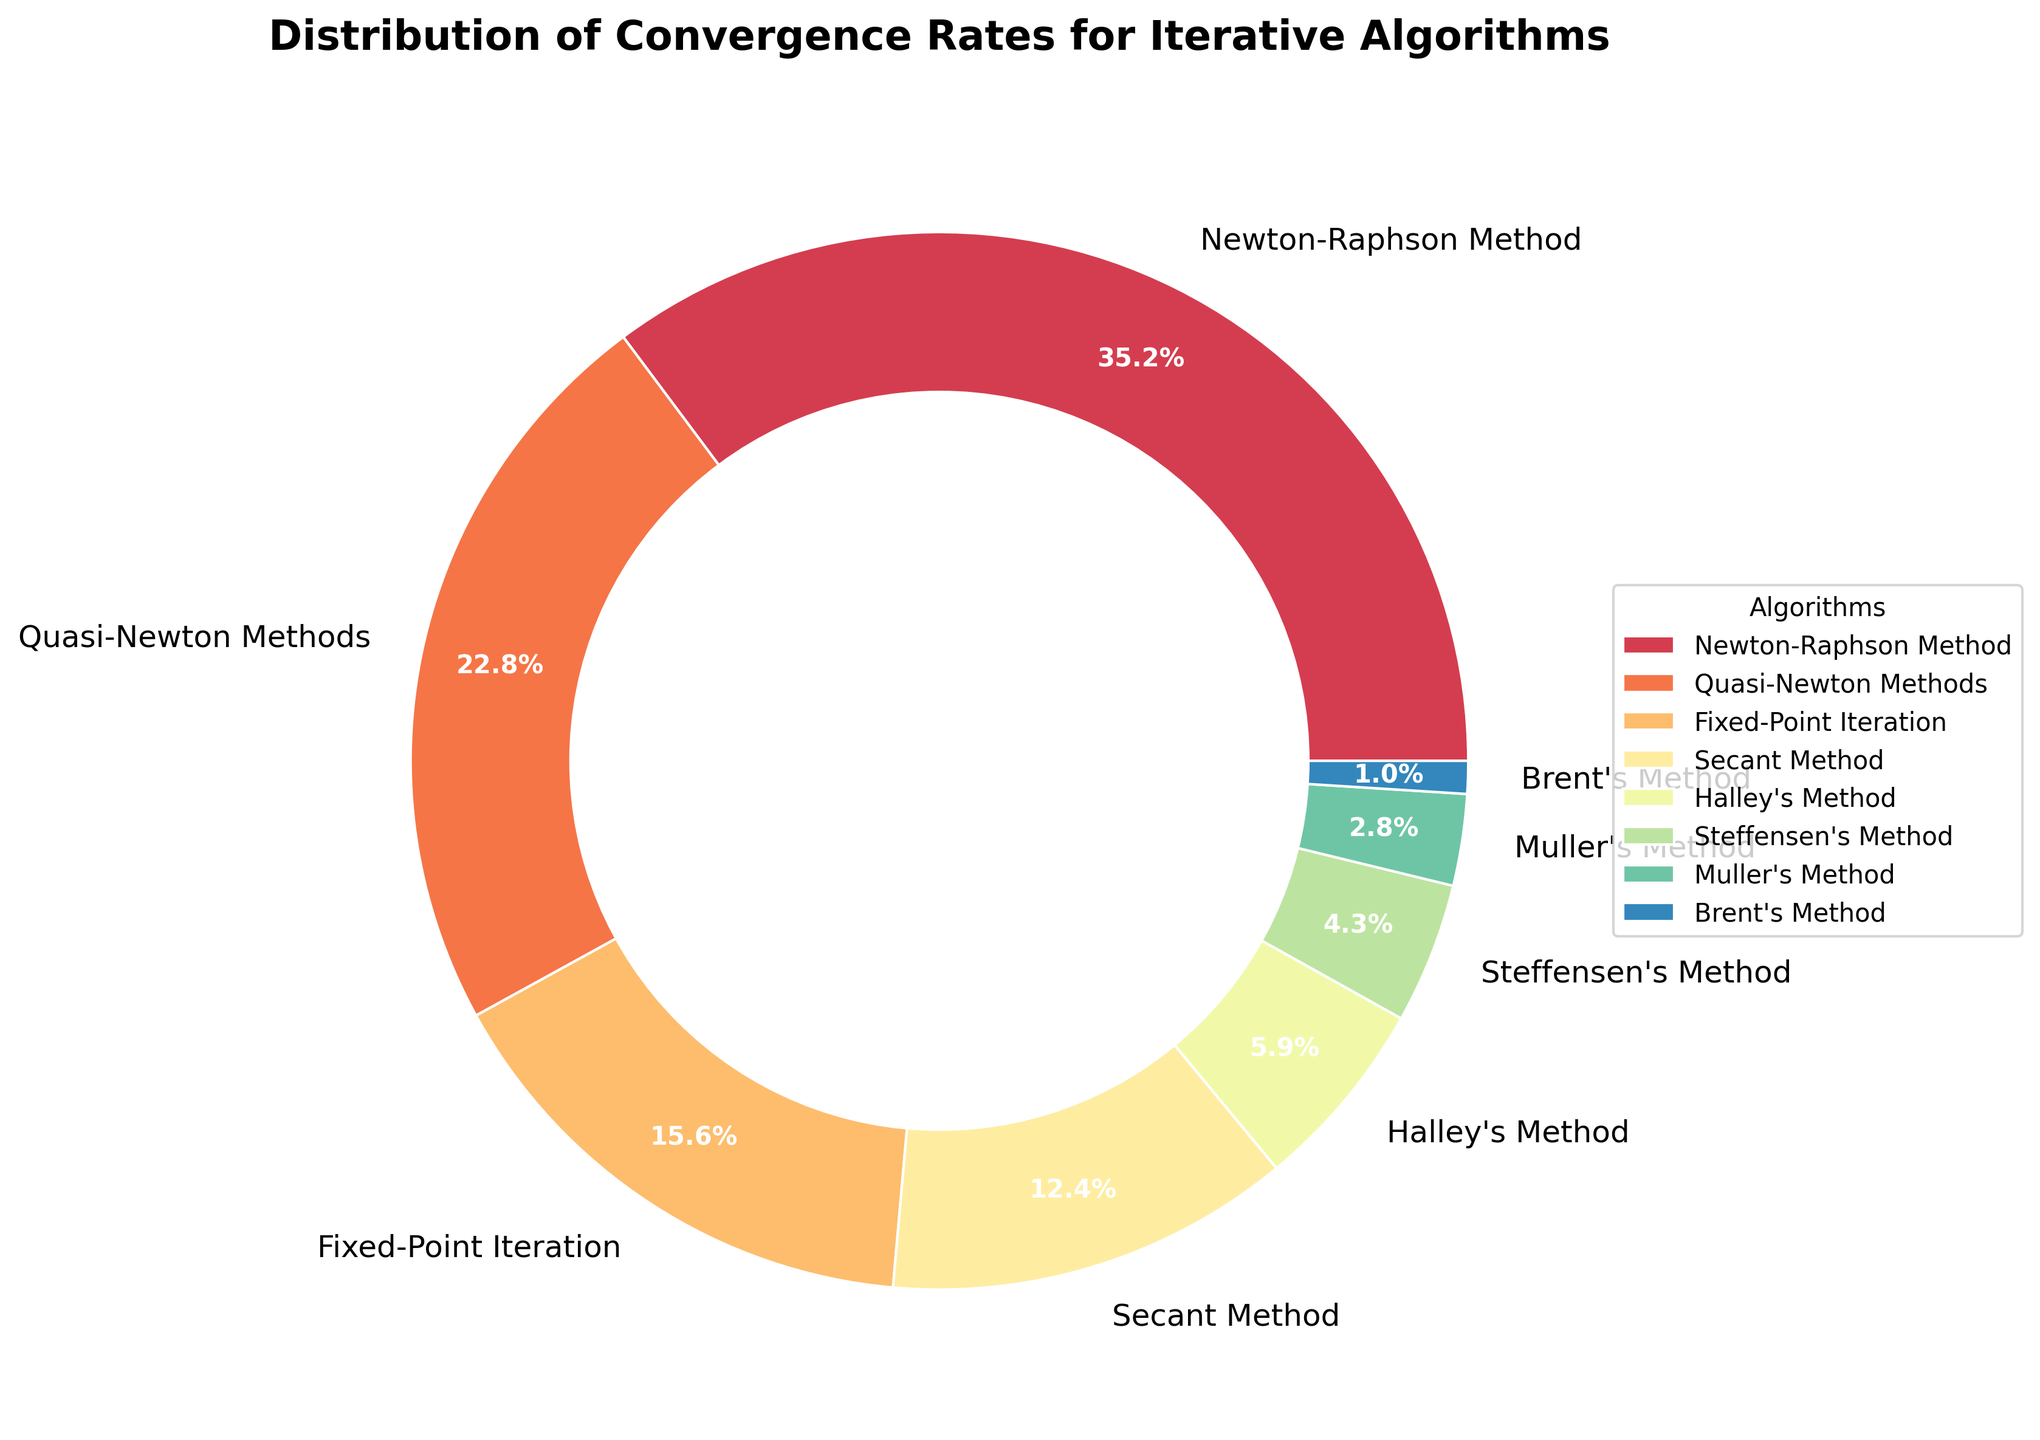What's the percentage contribution of Newton-Raphson Method and Quasi-Newton Methods combined? Add the percentages of Newton-Raphson Method (35.2%) and Quasi-Newton Methods (22.8%). The sum is 35.2% + 22.8% = 58%
Answer: 58% Which algorithm has the lowest convergence rate? Look for the smallest percentage in the chart; Brent's Method has the lowest at 1.0%.
Answer: Brent's Method How much higher is the convergence rate of the Secant Method compared to Steffensen's Method? Subtract the percentage of Steffensen's Method (4.3%) from Secant Method (12.4%). The difference is 12.4% - 4.3% = 8.1%
Answer: 8.1% Which three algorithms have the highest convergence rates? Identify the top three percentages: Newton-Raphson Method (35.2%), Quasi-Newton Methods (22.8%), and Fixed-Point Iteration (15.6%).
Answer: Newton-Raphson Method, Quasi-Newton Methods, Fixed-Point Iteration What percentage of the convergence rates do all the methods except Newton-Raphson Method and Quasi-Newton Methods account for? Subtract the sum of Newton-Raphson Method and Quasi-Newton Methods from 100%. 100% - 58% = 42%
Answer: 42% If Fix-Point Iteration's rate were doubled, would it become the highest rate? Double Fixed-Point Iteration percentage (15.6%) to get 31.2%. Since 31.2% is less than Newton-Raphson Method's 35.2%, it wouldn't be the highest.
Answer: No Arrange the algorithms in descending order by their convergence rate percentages. Organize based on the given data: Newton-Raphson Method (35.2%), Quasi-Newton Methods (22.8%), Fixed-Point Iteration (15.6%), Secant Method (12.4%), Halley's Method (5.9%), Steffensen's Method (4.3%), Muller's Method (2.8%), Brent's Method (1.0%).
Answer: Newton-Raphson Method, Quasi-Newton Methods, Fixed-Point Iteration, Secant Method, Halley's Method, Steffensen's Method, Muller's Method, Brent's Method Is there any algorithm whose convergence rate is more than double another algorithm's rate? Compare each pair of algorithms. Newton-Raphson Method (35.2%) is more than twice the rate of Fixed-Point Iteration (15.6%).
Answer: Yes Which algorithm's wedge in the pie chart is immediately next to Halley's Method in a clockwise direction? Identify the neighboring wedges. Steffensen's Method is next to Halley's Method in clockwise direction.
Answer: Steffensen's Method 